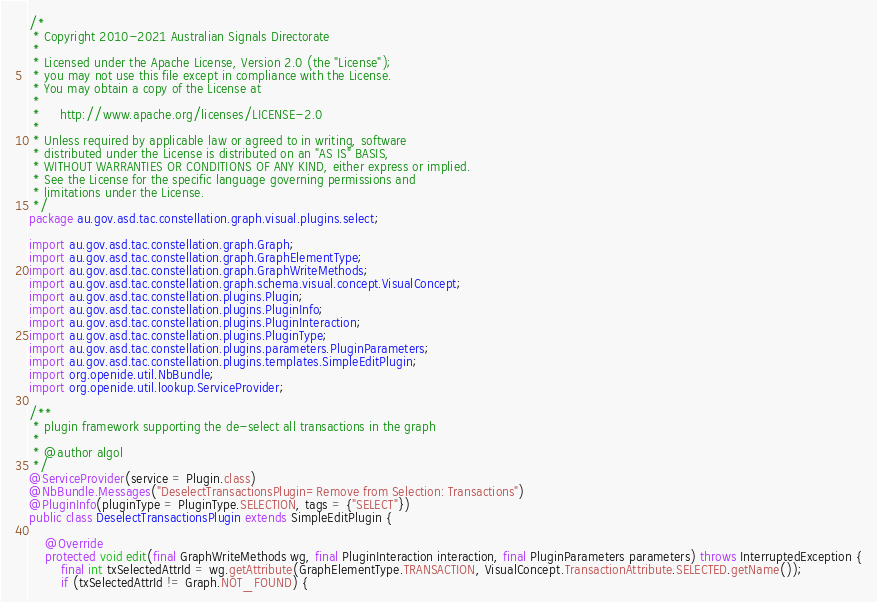<code> <loc_0><loc_0><loc_500><loc_500><_Java_>/*
 * Copyright 2010-2021 Australian Signals Directorate
 *
 * Licensed under the Apache License, Version 2.0 (the "License");
 * you may not use this file except in compliance with the License.
 * You may obtain a copy of the License at
 *
 *     http://www.apache.org/licenses/LICENSE-2.0
 *
 * Unless required by applicable law or agreed to in writing, software
 * distributed under the License is distributed on an "AS IS" BASIS,
 * WITHOUT WARRANTIES OR CONDITIONS OF ANY KIND, either express or implied.
 * See the License for the specific language governing permissions and
 * limitations under the License.
 */
package au.gov.asd.tac.constellation.graph.visual.plugins.select;

import au.gov.asd.tac.constellation.graph.Graph;
import au.gov.asd.tac.constellation.graph.GraphElementType;
import au.gov.asd.tac.constellation.graph.GraphWriteMethods;
import au.gov.asd.tac.constellation.graph.schema.visual.concept.VisualConcept;
import au.gov.asd.tac.constellation.plugins.Plugin;
import au.gov.asd.tac.constellation.plugins.PluginInfo;
import au.gov.asd.tac.constellation.plugins.PluginInteraction;
import au.gov.asd.tac.constellation.plugins.PluginType;
import au.gov.asd.tac.constellation.plugins.parameters.PluginParameters;
import au.gov.asd.tac.constellation.plugins.templates.SimpleEditPlugin;
import org.openide.util.NbBundle;
import org.openide.util.lookup.ServiceProvider;

/**
 * plugin framework supporting the de-select all transactions in the graph
 *
 * @author algol
 */
@ServiceProvider(service = Plugin.class)
@NbBundle.Messages("DeselectTransactionsPlugin=Remove from Selection: Transactions")
@PluginInfo(pluginType = PluginType.SELECTION, tags = {"SELECT"})
public class DeselectTransactionsPlugin extends SimpleEditPlugin {

    @Override
    protected void edit(final GraphWriteMethods wg, final PluginInteraction interaction, final PluginParameters parameters) throws InterruptedException {
        final int txSelectedAttrId = wg.getAttribute(GraphElementType.TRANSACTION, VisualConcept.TransactionAttribute.SELECTED.getName());
        if (txSelectedAttrId != Graph.NOT_FOUND) {</code> 